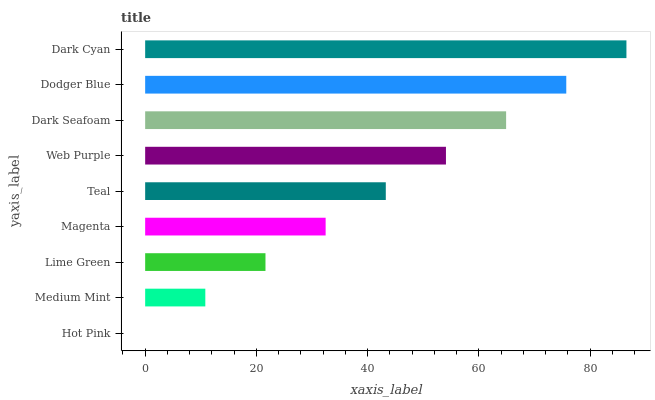Is Hot Pink the minimum?
Answer yes or no. Yes. Is Dark Cyan the maximum?
Answer yes or no. Yes. Is Medium Mint the minimum?
Answer yes or no. No. Is Medium Mint the maximum?
Answer yes or no. No. Is Medium Mint greater than Hot Pink?
Answer yes or no. Yes. Is Hot Pink less than Medium Mint?
Answer yes or no. Yes. Is Hot Pink greater than Medium Mint?
Answer yes or no. No. Is Medium Mint less than Hot Pink?
Answer yes or no. No. Is Teal the high median?
Answer yes or no. Yes. Is Teal the low median?
Answer yes or no. Yes. Is Magenta the high median?
Answer yes or no. No. Is Magenta the low median?
Answer yes or no. No. 